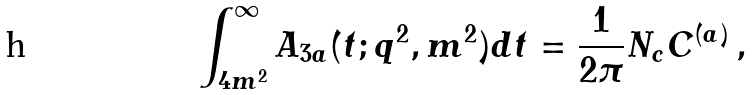<formula> <loc_0><loc_0><loc_500><loc_500>\int _ { 4 m ^ { 2 } } ^ { \infty } A _ { 3 a } ( t ; q ^ { 2 } , m ^ { 2 } ) d t = \frac { 1 } { 2 \pi } N _ { c } C ^ { ( a ) } \, ,</formula> 